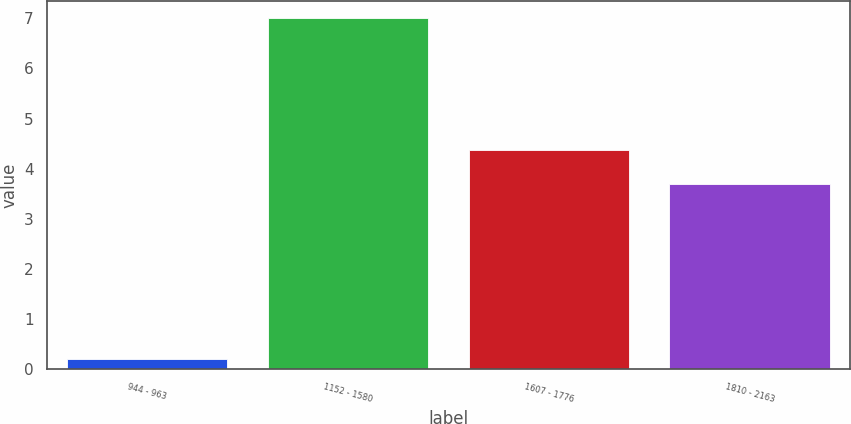Convert chart. <chart><loc_0><loc_0><loc_500><loc_500><bar_chart><fcel>944 - 963<fcel>1152 - 1580<fcel>1607 - 1776<fcel>1810 - 2163<nl><fcel>0.2<fcel>7<fcel>4.38<fcel>3.7<nl></chart> 